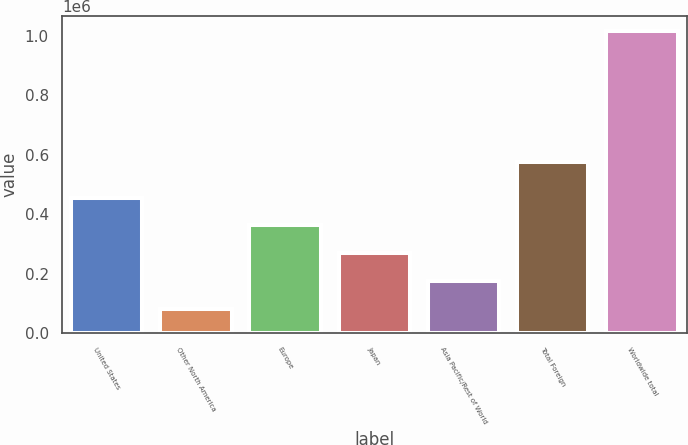<chart> <loc_0><loc_0><loc_500><loc_500><bar_chart><fcel>United States<fcel>Other North America<fcel>Europe<fcel>Japan<fcel>Asia Pacific/Rest of World<fcel>Total Foreign<fcel>Worldwide total<nl><fcel>455630<fcel>82330<fcel>362305<fcel>268980<fcel>175655<fcel>573667<fcel>1.01558e+06<nl></chart> 